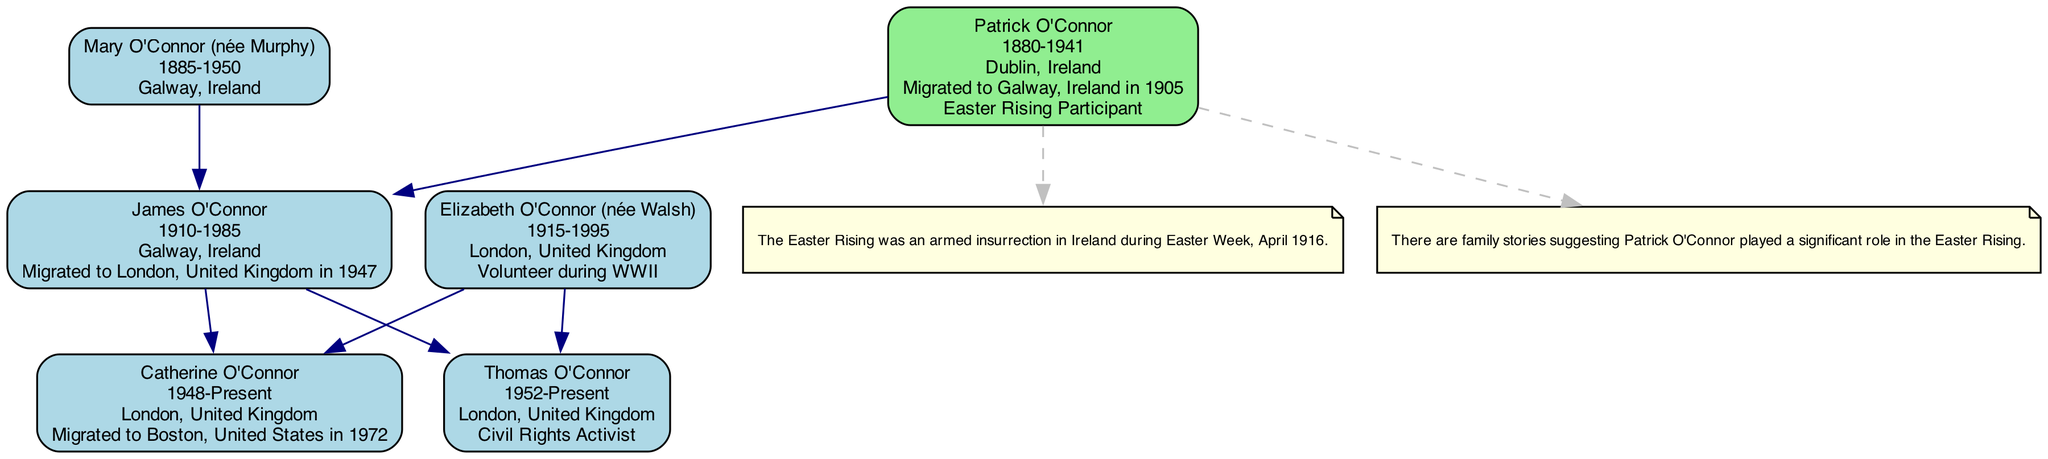What is the birthplace of Patrick O'Connor? In the diagram, Patrick O'Connor's details indicate that he was born in Dublin, Ireland.
Answer: Dublin, Ireland How many generations are represented in the family tree? The family tree has a total of 5 generations listed, from Patrick O'Connor to Thomas O'Connor.
Answer: 5 Who migrated to London in 1947? By reviewing the migration details, it is specified that James O'Connor migrated to London, United Kingdom in 1947.
Answer: James O'Connor What connection does Patrick O'Connor have in the family tree? The diagram highlights that Patrick O'Connor is noted as an Easter Rising Participant, showing his connection to this historical event.
Answer: Easter Rising Participant Which place did Catherine O'Connor migrate to in 1972? The migration entry in the diagram indicates that Catherine O'Connor moved to Boston, United States in 1972 for professional advancement.
Answer: Boston, United States What relationship connects James O'Connor to both Catherine and Thomas O'Connor? The diagram shows that both Catherine O'Connor and Thomas O'Connor are children of James O'Connor, establishing a parent-child relationship.
Answer: Father How many individuals participated in the Easter Rising within the family? According to the information in the diagram, only one individual, Patrick O'Connor, is noted as a participant in the Easter Rising.
Answer: 1 Which family member was born in 1915? The diagram indicates that Elizabeth O'Connor (née Walsh) was born in 1915, providing specific birth year information.
Answer: Elizabeth O'Connor (née Walsh) What notable connection does Thomas O'Connor have? From the diagram, it is clear that Thomas O'Connor is identified as a Civil Rights Activist, revealing an important aspect of his life.
Answer: Civil Rights Activist 